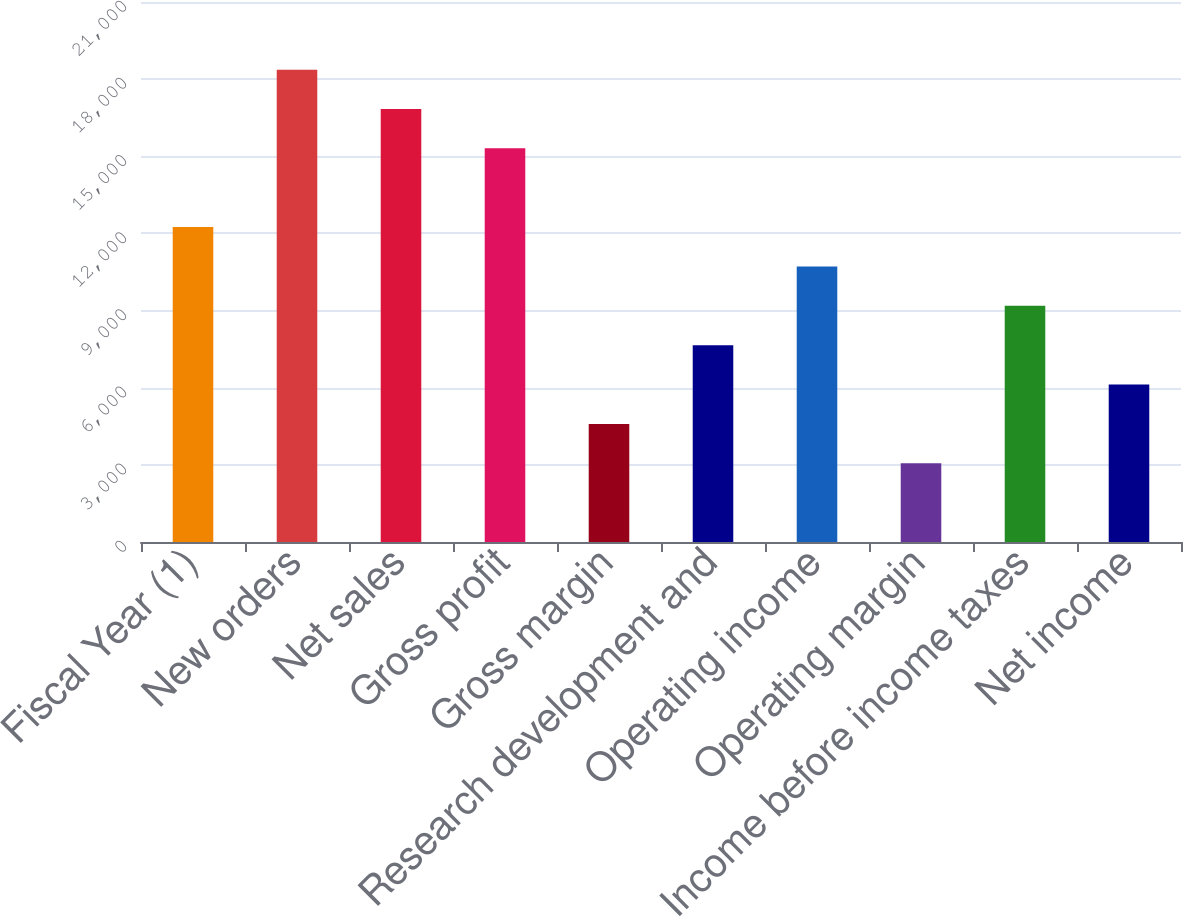<chart> <loc_0><loc_0><loc_500><loc_500><bar_chart><fcel>Fiscal Year (1)<fcel>New orders<fcel>Net sales<fcel>Gross profit<fcel>Gross margin<fcel>Research development and<fcel>Operating income<fcel>Operating margin<fcel>Income before income taxes<fcel>Net income<nl><fcel>12246.5<fcel>18369.5<fcel>16838.8<fcel>15308<fcel>4592.68<fcel>7654.2<fcel>10715.7<fcel>3061.92<fcel>9184.96<fcel>6123.44<nl></chart> 